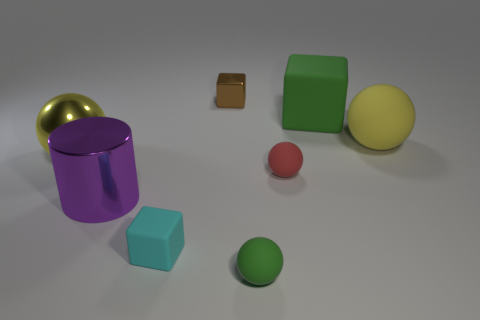What number of cylinders are either red things or big metallic things?
Offer a very short reply. 1. Are there fewer big spheres left of the large rubber sphere than large red rubber spheres?
Offer a very short reply. No. What is the shape of the small thing that is the same material as the big purple cylinder?
Give a very brief answer. Cube. How many other big metal cylinders have the same color as the large metal cylinder?
Keep it short and to the point. 0. How many things are tiny cyan shiny cylinders or green cubes?
Give a very brief answer. 1. There is a large yellow ball that is behind the big metal thing behind the big purple cylinder; what is its material?
Your answer should be very brief. Rubber. Are there any other large cubes that have the same material as the big cube?
Offer a very short reply. No. What shape is the large metal thing that is on the right side of the sphere that is to the left of the tiny block that is behind the green rubber cube?
Provide a succinct answer. Cylinder. What is the green cube made of?
Ensure brevity in your answer.  Rubber. What is the color of the big ball that is made of the same material as the big cube?
Offer a very short reply. Yellow. 